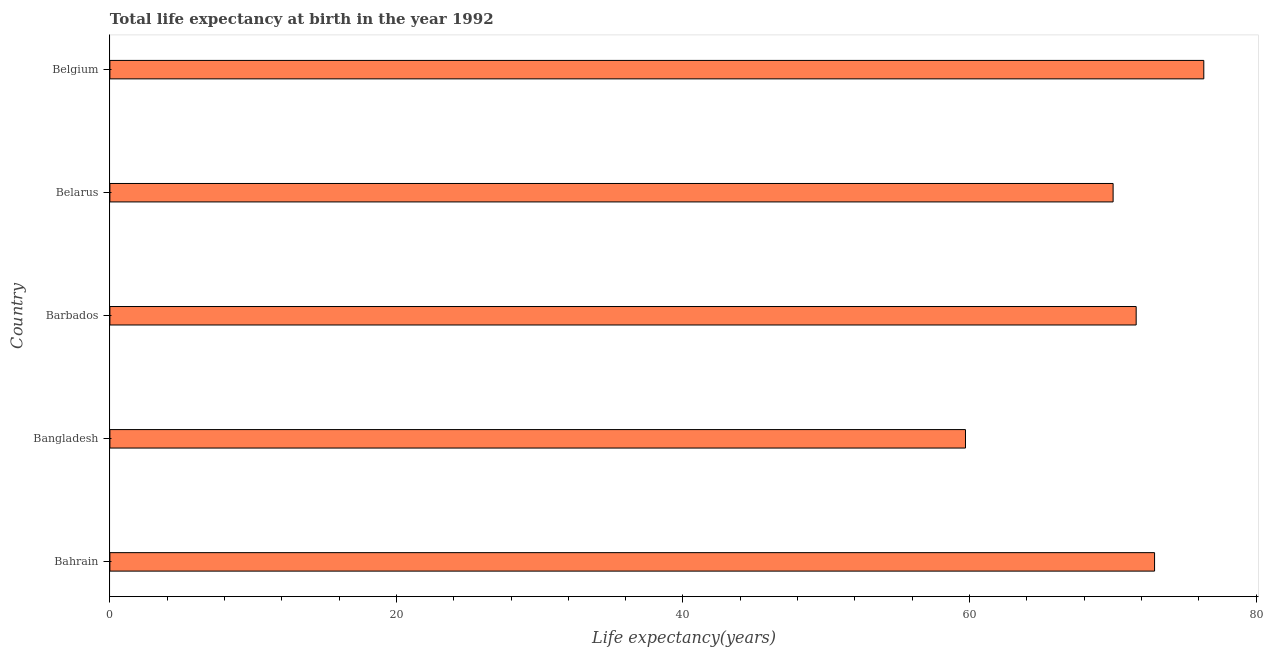Does the graph contain any zero values?
Your answer should be very brief. No. Does the graph contain grids?
Your response must be concise. No. What is the title of the graph?
Your answer should be compact. Total life expectancy at birth in the year 1992. What is the label or title of the X-axis?
Provide a short and direct response. Life expectancy(years). What is the label or title of the Y-axis?
Offer a terse response. Country. What is the life expectancy at birth in Belgium?
Give a very brief answer. 76.35. Across all countries, what is the maximum life expectancy at birth?
Keep it short and to the point. 76.35. Across all countries, what is the minimum life expectancy at birth?
Ensure brevity in your answer.  59.72. In which country was the life expectancy at birth minimum?
Give a very brief answer. Bangladesh. What is the sum of the life expectancy at birth?
Provide a succinct answer. 350.64. What is the difference between the life expectancy at birth in Bangladesh and Belgium?
Keep it short and to the point. -16.63. What is the average life expectancy at birth per country?
Your answer should be very brief. 70.13. What is the median life expectancy at birth?
Ensure brevity in your answer.  71.63. What is the ratio of the life expectancy at birth in Bahrain to that in Bangladesh?
Your answer should be very brief. 1.22. Is the difference between the life expectancy at birth in Barbados and Belarus greater than the difference between any two countries?
Offer a very short reply. No. What is the difference between the highest and the second highest life expectancy at birth?
Keep it short and to the point. 3.44. What is the difference between the highest and the lowest life expectancy at birth?
Your response must be concise. 16.63. In how many countries, is the life expectancy at birth greater than the average life expectancy at birth taken over all countries?
Offer a very short reply. 3. How many bars are there?
Offer a terse response. 5. How many countries are there in the graph?
Give a very brief answer. 5. Are the values on the major ticks of X-axis written in scientific E-notation?
Keep it short and to the point. No. What is the Life expectancy(years) in Bahrain?
Your response must be concise. 72.91. What is the Life expectancy(years) in Bangladesh?
Provide a short and direct response. 59.72. What is the Life expectancy(years) in Barbados?
Ensure brevity in your answer.  71.63. What is the Life expectancy(years) in Belarus?
Offer a very short reply. 70.02. What is the Life expectancy(years) in Belgium?
Your answer should be compact. 76.35. What is the difference between the Life expectancy(years) in Bahrain and Bangladesh?
Ensure brevity in your answer.  13.2. What is the difference between the Life expectancy(years) in Bahrain and Barbados?
Give a very brief answer. 1.28. What is the difference between the Life expectancy(years) in Bahrain and Belarus?
Keep it short and to the point. 2.89. What is the difference between the Life expectancy(years) in Bahrain and Belgium?
Your response must be concise. -3.44. What is the difference between the Life expectancy(years) in Bangladesh and Barbados?
Ensure brevity in your answer.  -11.91. What is the difference between the Life expectancy(years) in Bangladesh and Belarus?
Offer a terse response. -10.3. What is the difference between the Life expectancy(years) in Bangladesh and Belgium?
Ensure brevity in your answer.  -16.63. What is the difference between the Life expectancy(years) in Barbados and Belarus?
Your answer should be very brief. 1.61. What is the difference between the Life expectancy(years) in Barbados and Belgium?
Provide a succinct answer. -4.72. What is the difference between the Life expectancy(years) in Belarus and Belgium?
Your answer should be compact. -6.33. What is the ratio of the Life expectancy(years) in Bahrain to that in Bangladesh?
Give a very brief answer. 1.22. What is the ratio of the Life expectancy(years) in Bahrain to that in Belarus?
Make the answer very short. 1.04. What is the ratio of the Life expectancy(years) in Bahrain to that in Belgium?
Your answer should be very brief. 0.95. What is the ratio of the Life expectancy(years) in Bangladesh to that in Barbados?
Provide a short and direct response. 0.83. What is the ratio of the Life expectancy(years) in Bangladesh to that in Belarus?
Provide a succinct answer. 0.85. What is the ratio of the Life expectancy(years) in Bangladesh to that in Belgium?
Offer a terse response. 0.78. What is the ratio of the Life expectancy(years) in Barbados to that in Belarus?
Ensure brevity in your answer.  1.02. What is the ratio of the Life expectancy(years) in Barbados to that in Belgium?
Offer a terse response. 0.94. What is the ratio of the Life expectancy(years) in Belarus to that in Belgium?
Keep it short and to the point. 0.92. 